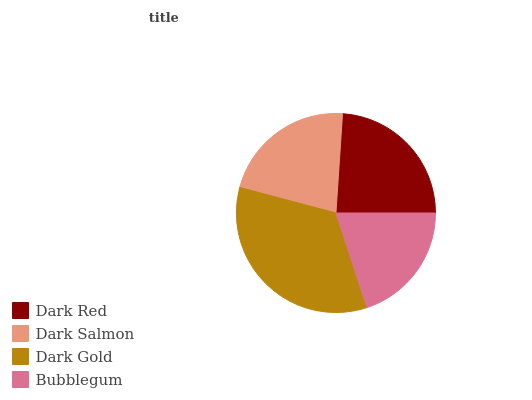Is Bubblegum the minimum?
Answer yes or no. Yes. Is Dark Gold the maximum?
Answer yes or no. Yes. Is Dark Salmon the minimum?
Answer yes or no. No. Is Dark Salmon the maximum?
Answer yes or no. No. Is Dark Red greater than Dark Salmon?
Answer yes or no. Yes. Is Dark Salmon less than Dark Red?
Answer yes or no. Yes. Is Dark Salmon greater than Dark Red?
Answer yes or no. No. Is Dark Red less than Dark Salmon?
Answer yes or no. No. Is Dark Red the high median?
Answer yes or no. Yes. Is Dark Salmon the low median?
Answer yes or no. Yes. Is Dark Salmon the high median?
Answer yes or no. No. Is Bubblegum the low median?
Answer yes or no. No. 